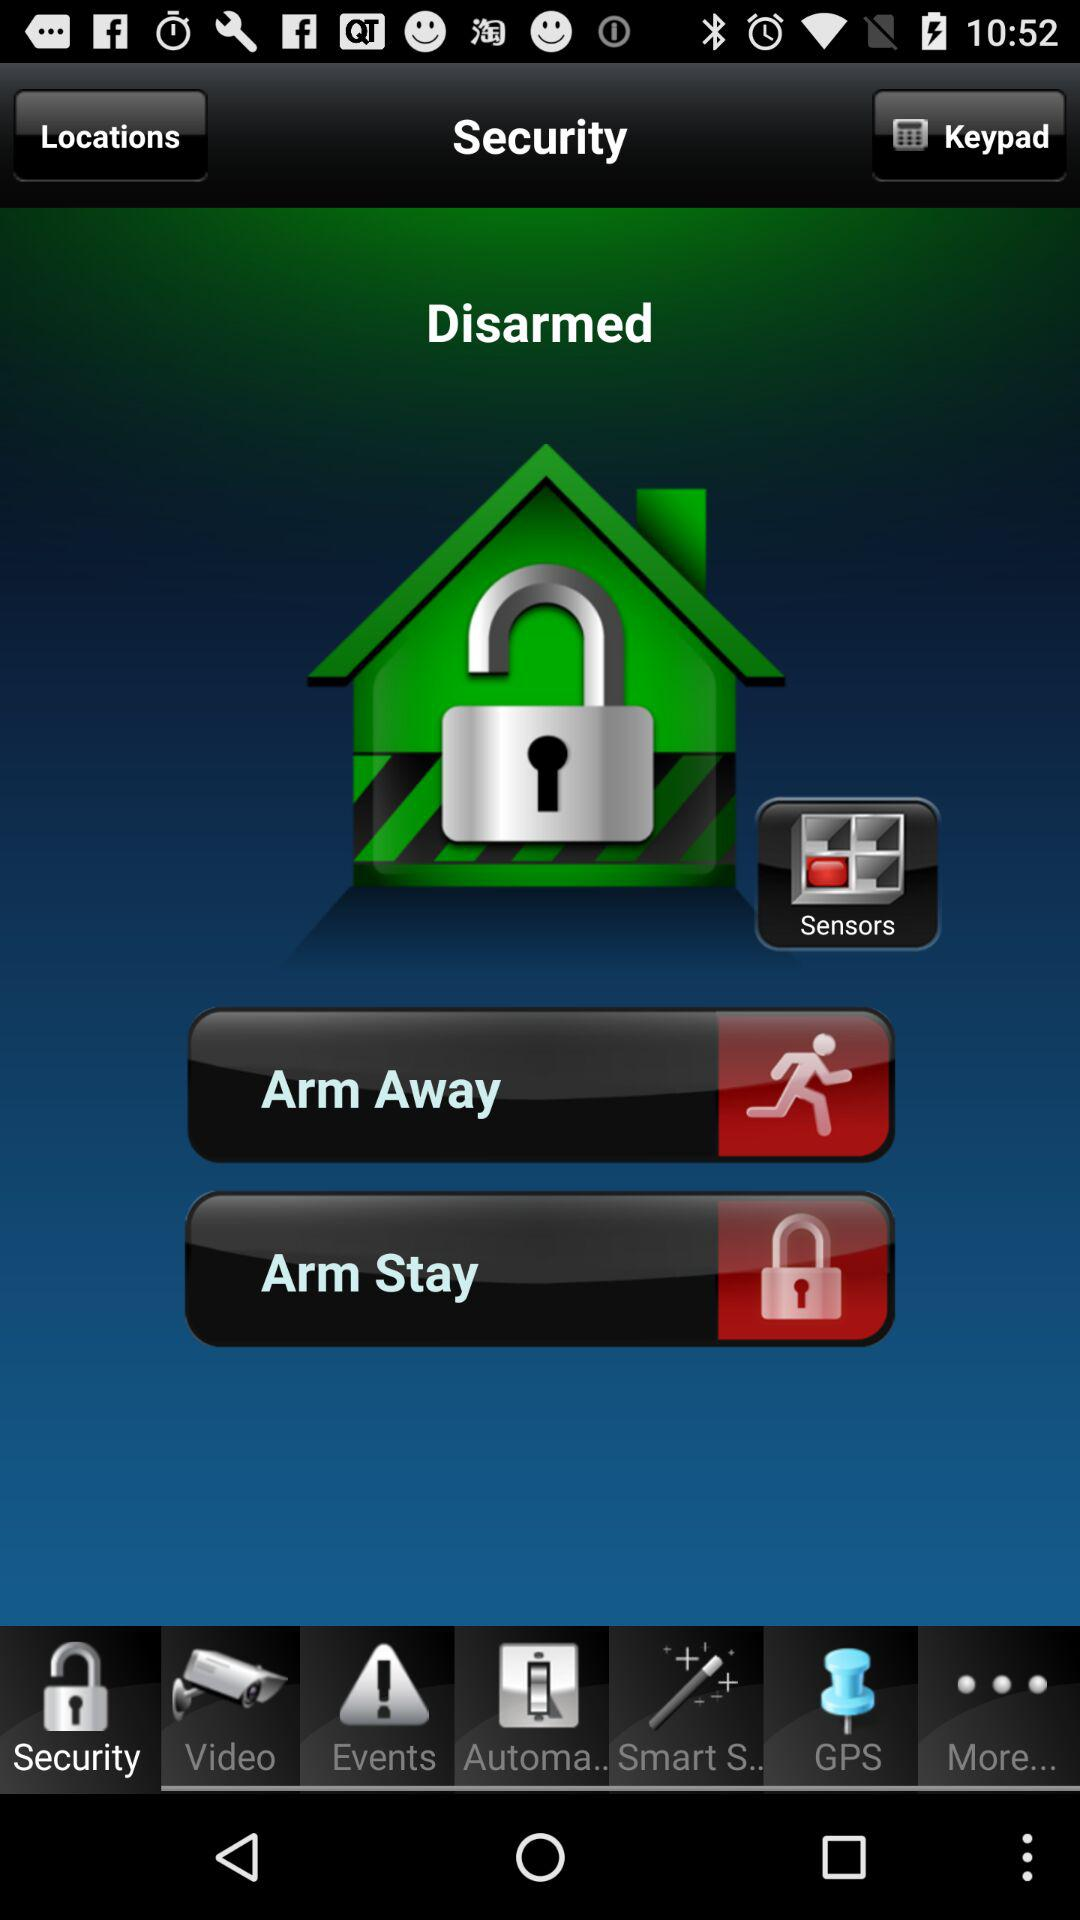Which tab is selected? The selected tab is "Security". 